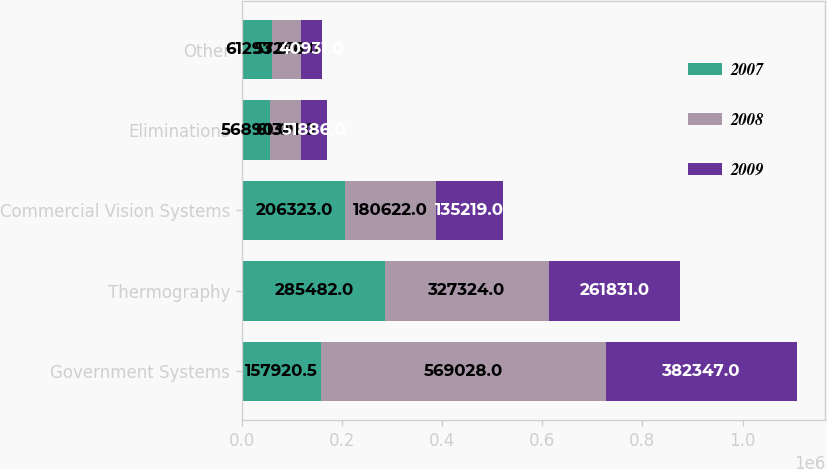<chart> <loc_0><loc_0><loc_500><loc_500><stacked_bar_chart><ecel><fcel>Government Systems<fcel>Thermography<fcel>Commercial Vision Systems<fcel>Eliminations<fcel>Other<nl><fcel>2007<fcel>157920<fcel>285482<fcel>206323<fcel>56890<fcel>61293<nl><fcel>2008<fcel>569028<fcel>327324<fcel>180622<fcel>61301<fcel>57276<nl><fcel>2009<fcel>382347<fcel>261831<fcel>135219<fcel>51886<fcel>40931<nl></chart> 